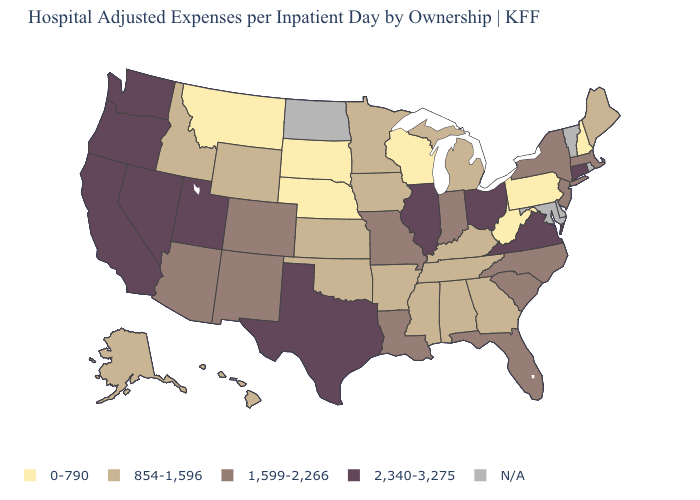Among the states that border Arkansas , which have the lowest value?
Quick response, please. Mississippi, Oklahoma, Tennessee. Does the map have missing data?
Keep it brief. Yes. Which states hav the highest value in the West?
Be succinct. California, Nevada, Oregon, Utah, Washington. How many symbols are there in the legend?
Keep it brief. 5. Among the states that border New York , which have the highest value?
Give a very brief answer. Connecticut. What is the highest value in the MidWest ?
Concise answer only. 2,340-3,275. Name the states that have a value in the range 1,599-2,266?
Be succinct. Arizona, Colorado, Florida, Indiana, Louisiana, Massachusetts, Missouri, New Jersey, New Mexico, New York, North Carolina, South Carolina. Name the states that have a value in the range 2,340-3,275?
Be succinct. California, Connecticut, Illinois, Nevada, Ohio, Oregon, Texas, Utah, Virginia, Washington. Among the states that border New Jersey , does Pennsylvania have the lowest value?
Concise answer only. Yes. Name the states that have a value in the range 2,340-3,275?
Give a very brief answer. California, Connecticut, Illinois, Nevada, Ohio, Oregon, Texas, Utah, Virginia, Washington. What is the value of Minnesota?
Short answer required. 854-1,596. What is the value of Kansas?
Answer briefly. 854-1,596. What is the value of New Jersey?
Answer briefly. 1,599-2,266. What is the value of Missouri?
Give a very brief answer. 1,599-2,266. Which states have the lowest value in the USA?
Be succinct. Montana, Nebraska, New Hampshire, Pennsylvania, South Dakota, West Virginia, Wisconsin. 